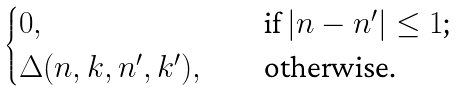Convert formula to latex. <formula><loc_0><loc_0><loc_500><loc_500>\begin{cases} 0 , & \quad \text {if $|n-n^{\prime}|\leq 1$;} \\ \Delta ( n , k , n ^ { \prime } , k ^ { \prime } ) , & \quad \text {otherwise.} \end{cases}</formula> 